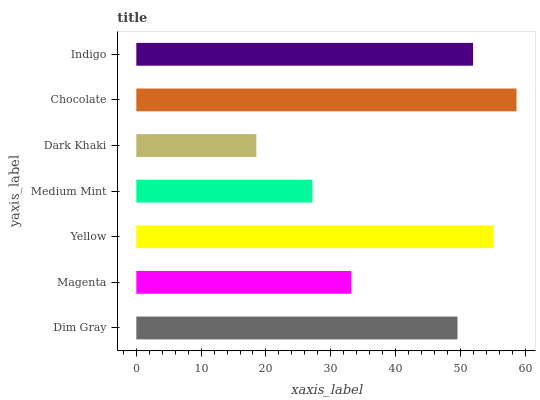Is Dark Khaki the minimum?
Answer yes or no. Yes. Is Chocolate the maximum?
Answer yes or no. Yes. Is Magenta the minimum?
Answer yes or no. No. Is Magenta the maximum?
Answer yes or no. No. Is Dim Gray greater than Magenta?
Answer yes or no. Yes. Is Magenta less than Dim Gray?
Answer yes or no. Yes. Is Magenta greater than Dim Gray?
Answer yes or no. No. Is Dim Gray less than Magenta?
Answer yes or no. No. Is Dim Gray the high median?
Answer yes or no. Yes. Is Dim Gray the low median?
Answer yes or no. Yes. Is Medium Mint the high median?
Answer yes or no. No. Is Yellow the low median?
Answer yes or no. No. 